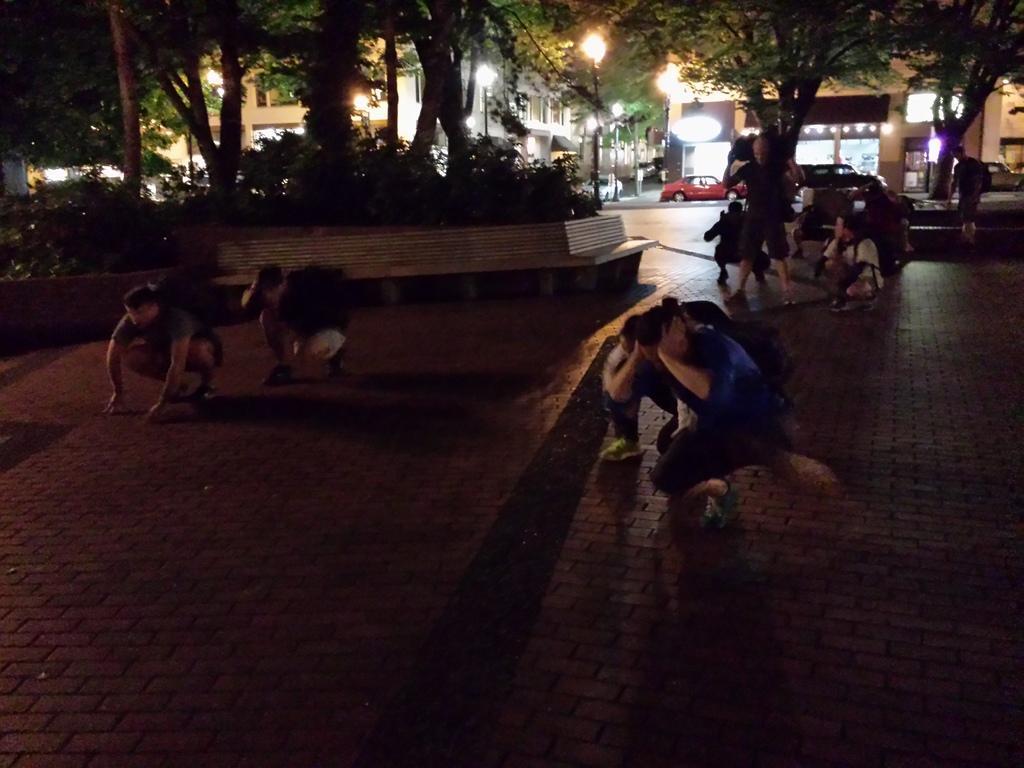Please provide a concise description of this image. In the image we can see there are people sitting on the ground and there are lot of trees. Behind there are buildings and there are cars parked on the road. 